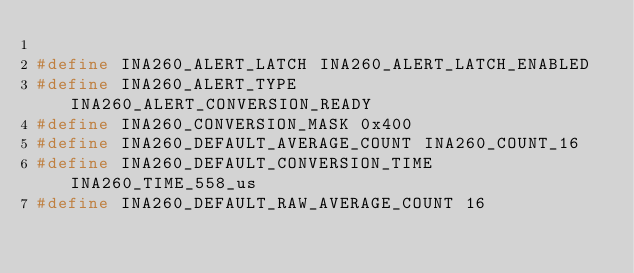Convert code to text. <code><loc_0><loc_0><loc_500><loc_500><_C_>
#define INA260_ALERT_LATCH INA260_ALERT_LATCH_ENABLED
#define INA260_ALERT_TYPE INA260_ALERT_CONVERSION_READY
#define INA260_CONVERSION_MASK 0x400
#define INA260_DEFAULT_AVERAGE_COUNT INA260_COUNT_16
#define INA260_DEFAULT_CONVERSION_TIME INA260_TIME_558_us
#define INA260_DEFAULT_RAW_AVERAGE_COUNT 16</code> 